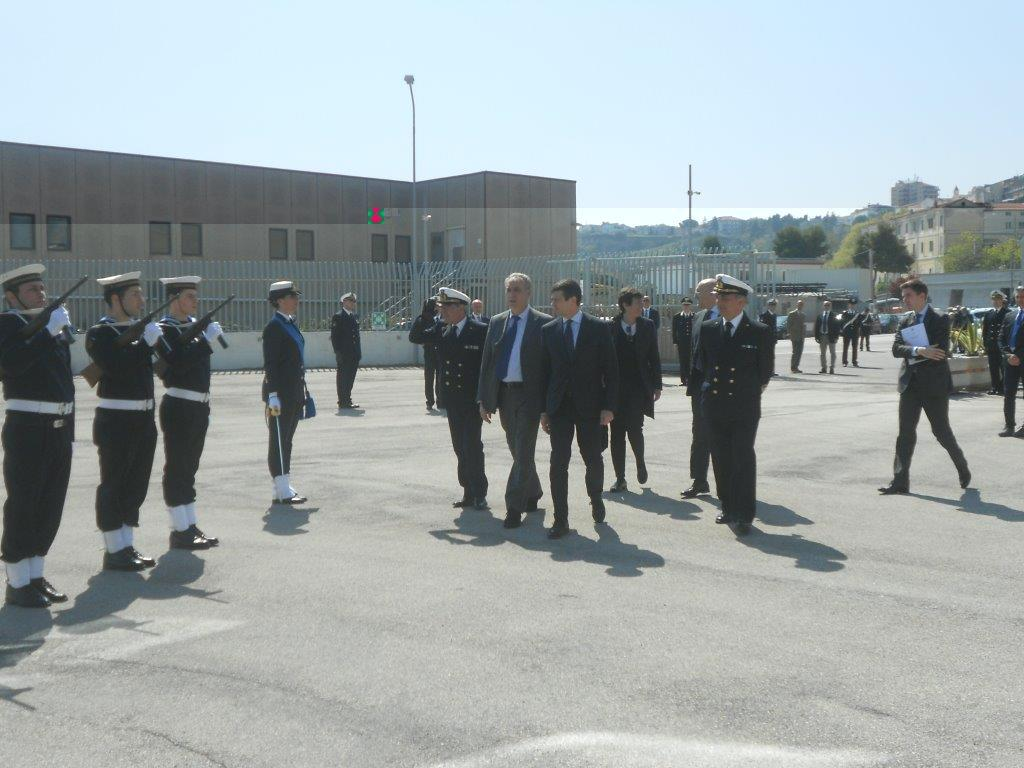What can be seen in the image? There are persons standing in the image. What is visible in the background of the image? There are buildings and trees in the background of the image. What color is the balloon that the person is holding in the image? There is no balloon present in the image. How fast are the persons running in the image? The persons are not running in the image; they are standing still. 